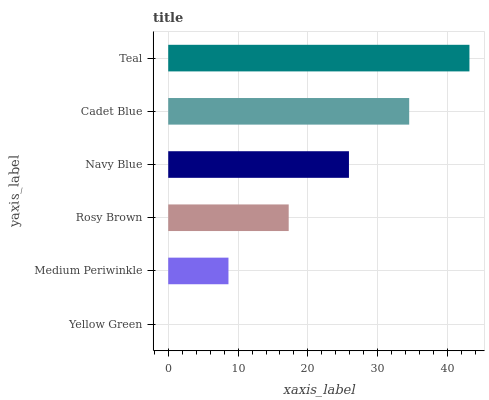Is Yellow Green the minimum?
Answer yes or no. Yes. Is Teal the maximum?
Answer yes or no. Yes. Is Medium Periwinkle the minimum?
Answer yes or no. No. Is Medium Periwinkle the maximum?
Answer yes or no. No. Is Medium Periwinkle greater than Yellow Green?
Answer yes or no. Yes. Is Yellow Green less than Medium Periwinkle?
Answer yes or no. Yes. Is Yellow Green greater than Medium Periwinkle?
Answer yes or no. No. Is Medium Periwinkle less than Yellow Green?
Answer yes or no. No. Is Navy Blue the high median?
Answer yes or no. Yes. Is Rosy Brown the low median?
Answer yes or no. Yes. Is Yellow Green the high median?
Answer yes or no. No. Is Cadet Blue the low median?
Answer yes or no. No. 